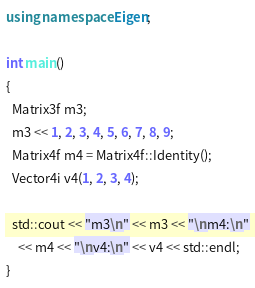Convert code to text. <code><loc_0><loc_0><loc_500><loc_500><_C++_>


using namespace Eigen;

int main()
{
  Matrix3f m3;
  m3 << 1, 2, 3, 4, 5, 6, 7, 8, 9;
  Matrix4f m4 = Matrix4f::Identity();
  Vector4i v4(1, 2, 3, 4);

  std::cout << "m3\n" << m3 << "\nm4:\n"
    << m4 << "\nv4:\n" << v4 << std::endl;
}
</code> 